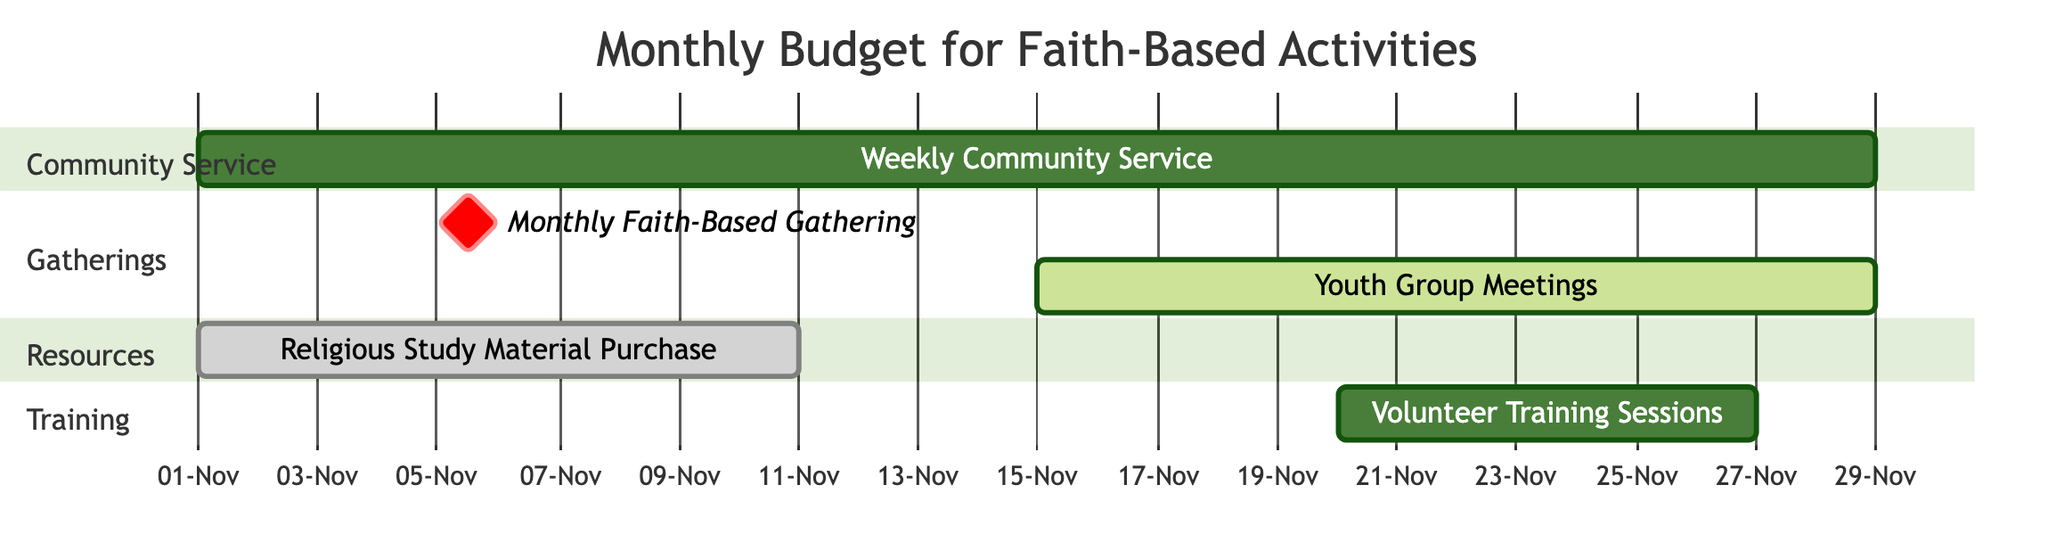What is the duration of the Weekly Community Service? The Weekly Community Service is scheduled for 4 weeks as indicated by its duration noted directly next to the activity bar in the Gantt chart.
Answer: 4 weeks How many activities are scheduled for November 2023? By counting the individual activities displayed in the Gantt chart for November 2023, there are five activities listed in total.
Answer: 5 What is the start date for the Religious Study Material Purchase? The Gantt chart specifies that the start date for the Religious Study Material Purchase is November 1, 2023, which is marked on the horizontal timeline of the diagram.
Answer: November 1, 2023 Which activity has a one-time frequency? In the diagram, both the Religious Study Material Purchase and the Volunteer Training Sessions are labeled as having a one-time frequency, making them the activities that fit this criterion.
Answer: Religious Study Material Purchase, Volunteer Training Sessions Which activities overlap in their timeframes? The Weekly Community Service, which lasts from November 1 to November 30, overlaps with both the Volunteer Training Sessions and the Religious Study Material Purchase, which runs from November 1 to November 10, creating a period of overlap.
Answer: Weekly Community Service, Religious Study Material Purchase When is the Monthly Faith-Based Gathering scheduled? The Monthly Faith-Based Gathering occurs specifically on November 5, 2023, as denoted by the milestone marking in the Gantt chart for that date.
Answer: November 5, 2023 What is the frequency of the Youth Group Meetings? The diagram indicates that the Youth Group Meetings occur bi-weekly, as specified next to the activity's timeline on the Gantt chart.
Answer: Bi-weekly How long will the Volunteer Training Sessions last? According to the Gantt chart, the Volunteer Training Sessions are scheduled for 1 week, as indicated by the duration next to the activity in the diagram.
Answer: 1 week Which section in the Gantt chart features activities related to community service? The section titled "Community Service" includes the activity named Weekly Community Service, as seen in the layout of the Gantt chart.
Answer: Community Service What is the end date for Youth Group Meetings? The Gantt chart indicates the end date for the Youth Group Meetings is November 29, 2023, which is displayed on the timeline associated with that specific activity.
Answer: November 29, 2023 